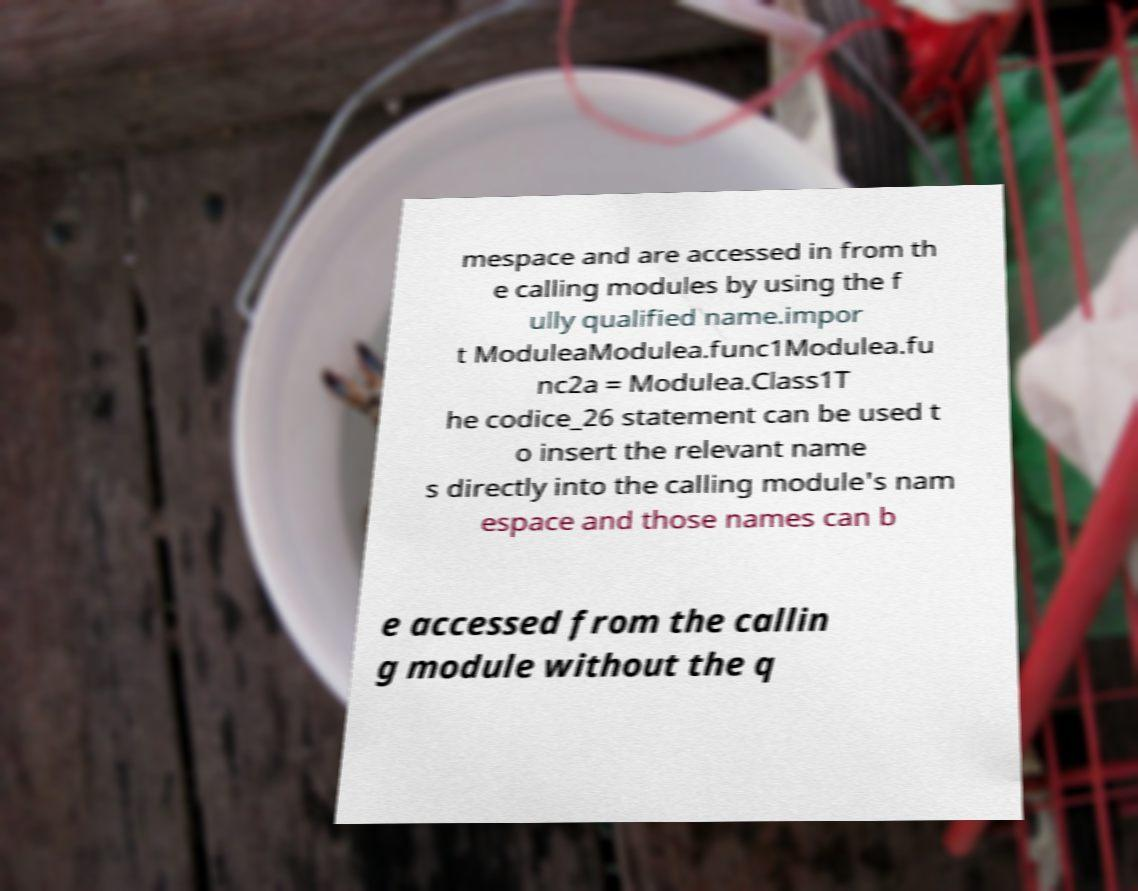For documentation purposes, I need the text within this image transcribed. Could you provide that? mespace and are accessed in from th e calling modules by using the f ully qualified name.impor t ModuleaModulea.func1Modulea.fu nc2a = Modulea.Class1T he codice_26 statement can be used t o insert the relevant name s directly into the calling module's nam espace and those names can b e accessed from the callin g module without the q 